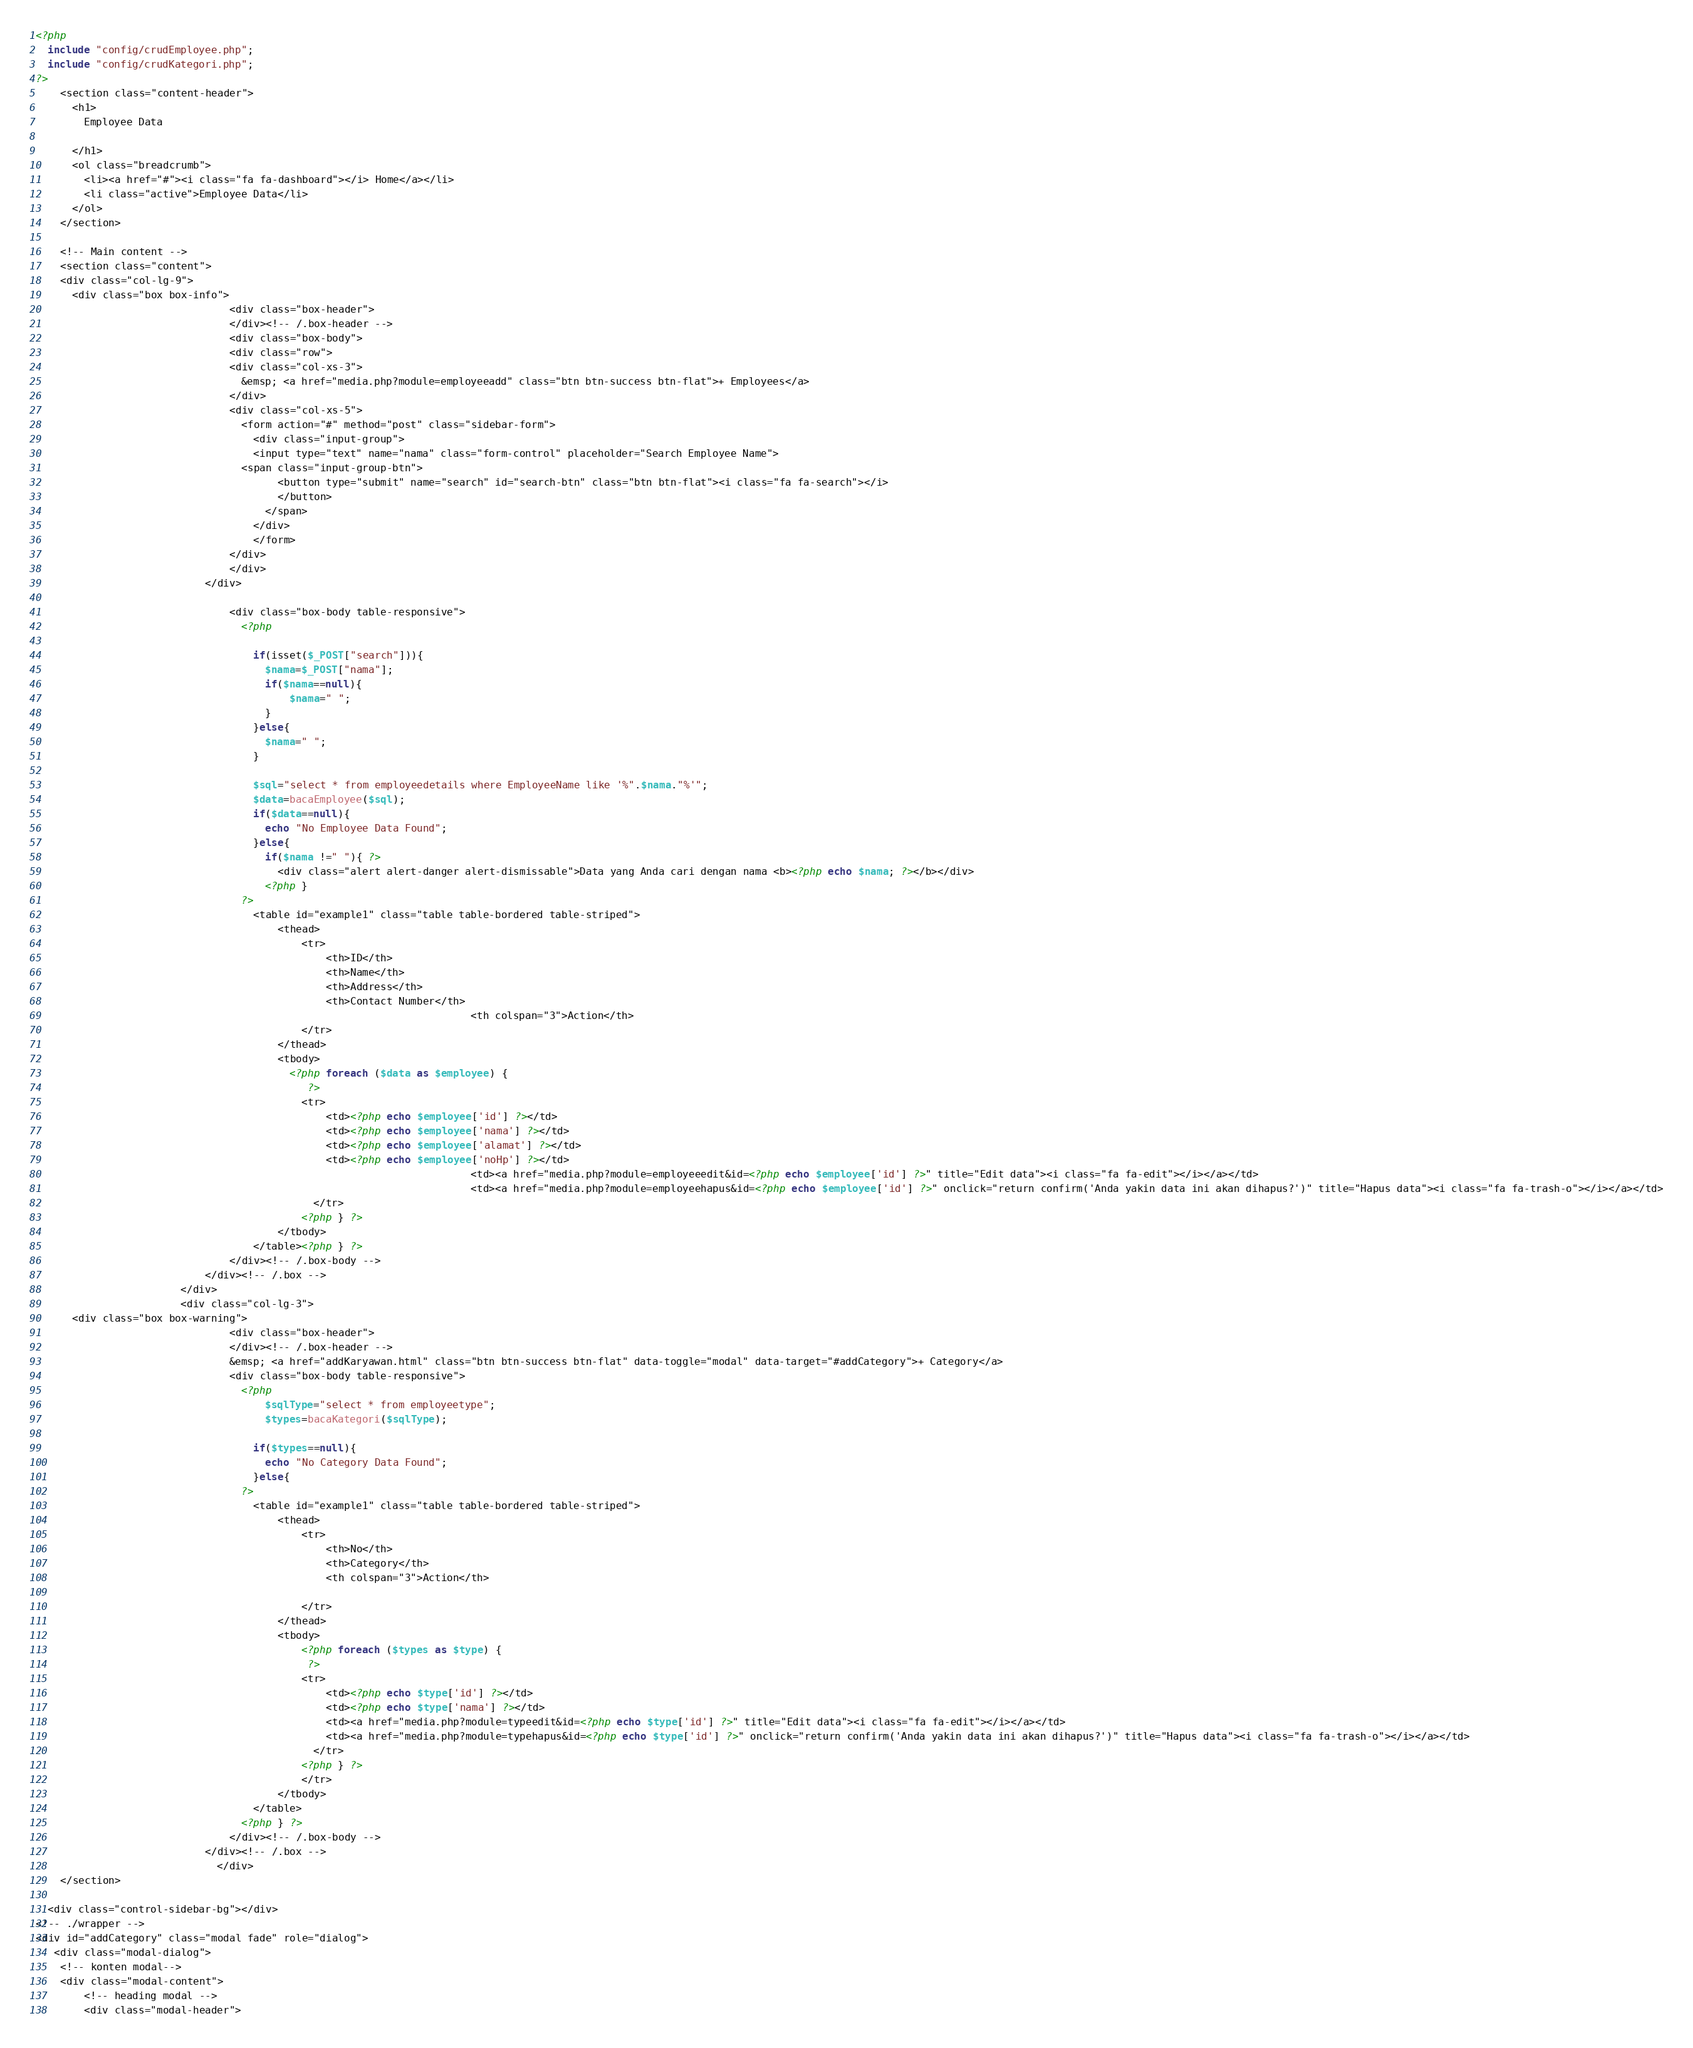<code> <loc_0><loc_0><loc_500><loc_500><_PHP_><?php
  include "config/crudEmployee.php";
  include "config/crudKategori.php";
?>
    <section class="content-header">
      <h1>
        Employee Data
        
      </h1>
      <ol class="breadcrumb">
        <li><a href="#"><i class="fa fa-dashboard"></i> Home</a></li>
        <li class="active">Employee Data</li>
      </ol>
    </section>

    <!-- Main content -->
    <section class="content">
	<div class="col-lg-9">
      <div class="box box-info">
                                <div class="box-header">
                                </div><!-- /.box-header -->
								<div class="box-body">
								<div class="row">
								<div class="col-xs-3">
								  &emsp; <a href="media.php?module=employeeadd" class="btn btn-success btn-flat">+ Employees</a>
								</div>				
								<div class="col-xs-5">
								  <form action="#" method="post" class="sidebar-form">
									<div class="input-group">
									<input type="text" name="nama" class="form-control" placeholder="Search Employee Name">
								  <span class="input-group-btn">
										<button type="submit" name="search" id="search-btn" class="btn btn-flat"><i class="fa fa-search"></i>
										</button>
									  </span>
									</div>
									</form>
								</div>
								</div>
							</div>
					
                                <div class="box-body table-responsive">
                                  <?php

                                    if(isset($_POST["search"])){
                                      $nama=$_POST["nama"]; 
                                      if($nama==null){
                                          $nama=" ";
                                      } 
                                    }else{
                                      $nama=" ";
                                    }
                                    
                                    $sql="select * from employeedetails where EmployeeName like '%".$nama."%'";
                                    $data=bacaEmployee($sql);
                                    if($data==null){
                                      echo "No Employee Data Found";
                                    }else{
                                      if($nama !=" "){ ?>
                                        <div class="alert alert-danger alert-dismissable">Data yang Anda cari dengan nama <b><?php echo $nama; ?></b></div>
                                      <?php }
                                  ?>
                                    <table id="example1" class="table table-bordered table-striped">
                                        <thead>
                                            <tr>
                                                <th>ID</th>
                                                <th>Name</th>
                                                <th>Address</th>
                                                <th>Contact Number</th>
												                        <th colspan="3">Action</th>
                                            </tr>
                                        </thead>
                                        <tbody>
                                          <?php foreach ($data as $employee) {
                                             ?>
                                            <tr>
                                                <td><?php echo $employee['id'] ?></td>
                                                <td><?php echo $employee['nama'] ?></td>
                                                <td><?php echo $employee['alamat'] ?></td>
                                                <td><?php echo $employee['noHp'] ?></td>
                        												<td><a href="media.php?module=employeeedit&id=<?php echo $employee['id'] ?>" title="Edit data"><i class="fa fa-edit"></i></a></td>
                        												<td><a href="media.php?module=employeehapus&id=<?php echo $employee['id'] ?>" onclick="return confirm('Anda yakin data ini akan dihapus?')" title="Hapus data"><i class="fa fa-trash-o"></i></a></td>
                                              </tr>
                                            <?php } ?>  
                                        </tbody>
                                    </table><?php } ?>
                                </div><!-- /.box-body -->
                            </div><!-- /.box -->
						</div>
						<div class="col-lg-3">
      <div class="box box-warning">
                                <div class="box-header">
                                </div><!-- /.box-header -->
								&emsp; <a href="addKaryawan.html" class="btn btn-success btn-flat" data-toggle="modal" data-target="#addCategory">+ Category</a>
                                <div class="box-body table-responsive">
                                  <?php
                                      $sqlType="select * from employeetype";
                                      $types=bacaKategori($sqlType);

                                    if($types==null){
                                      echo "No Category Data Found";
                                    }else{
                                  ?>
                                    <table id="example1" class="table table-bordered table-striped">
                                        <thead>
                                            <tr>
                                                <th>No</th>
                                                <th>Category</th>
												<th colspan="3">Action</th>
							
                                            </tr>
                                        </thead>
                                        <tbody>
                                            <?php foreach ($types as $type) {
                                             ?>
                                            <tr>
                                                <td><?php echo $type['id'] ?></td>
                                                <td><?php echo $type['nama'] ?></td>
                                                <td><a href="media.php?module=typeedit&id=<?php echo $type['id'] ?>" title="Edit data"><i class="fa fa-edit"></i></a></td>
                                                <td><a href="media.php?module=typehapus&id=<?php echo $type['id'] ?>" onclick="return confirm('Anda yakin data ini akan dihapus?')" title="Hapus data"><i class="fa fa-trash-o"></i></a></td>
                                              </tr>
                                            <?php } ?>  
                                            </tr>
                                        </tbody>
                                    </table>
                                  <?php } ?>
                                </div><!-- /.box-body -->
                            </div><!-- /.box -->
							  </div>
    </section>

  <div class="control-sidebar-bg"></div>
<!-- ./wrapper -->
<div id="addCategory" class="modal fade" role="dialog">
   <div class="modal-dialog">
	<!-- konten modal-->
	<div class="modal-content">
		<!-- heading modal -->
		<div class="modal-header"></code> 